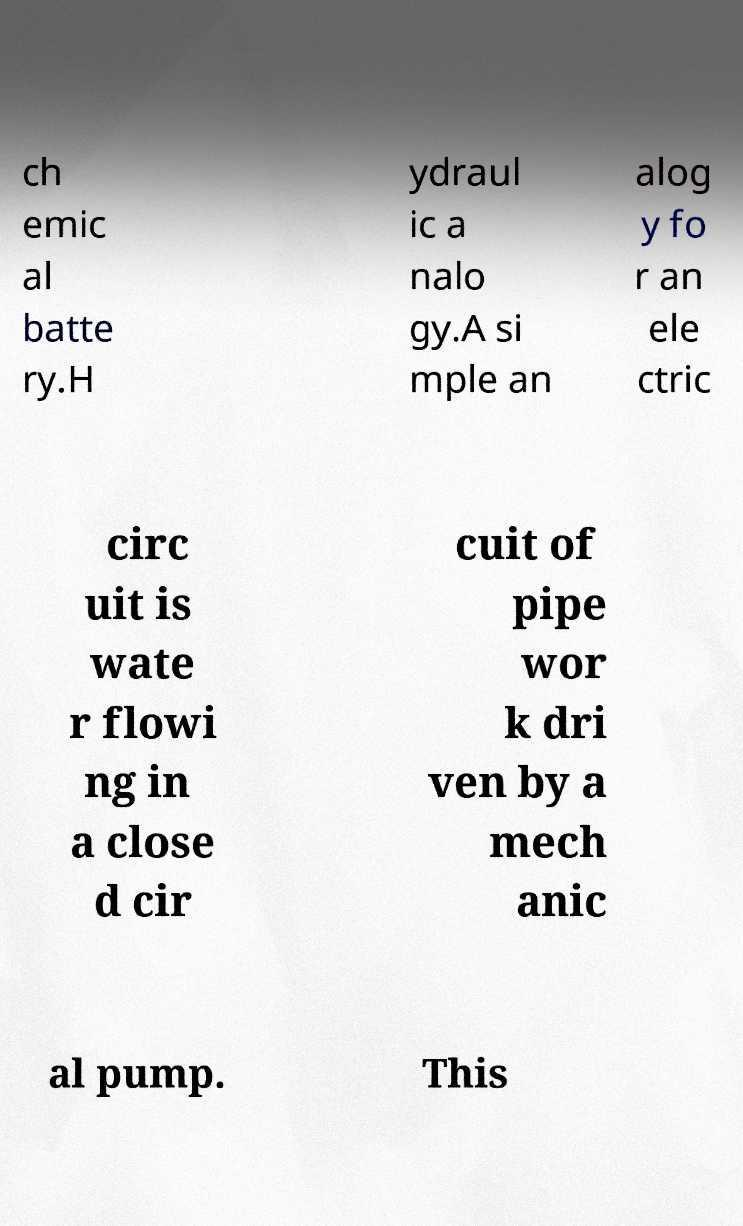What messages or text are displayed in this image? I need them in a readable, typed format. ch emic al batte ry.H ydraul ic a nalo gy.A si mple an alog y fo r an ele ctric circ uit is wate r flowi ng in a close d cir cuit of pipe wor k dri ven by a mech anic al pump. This 